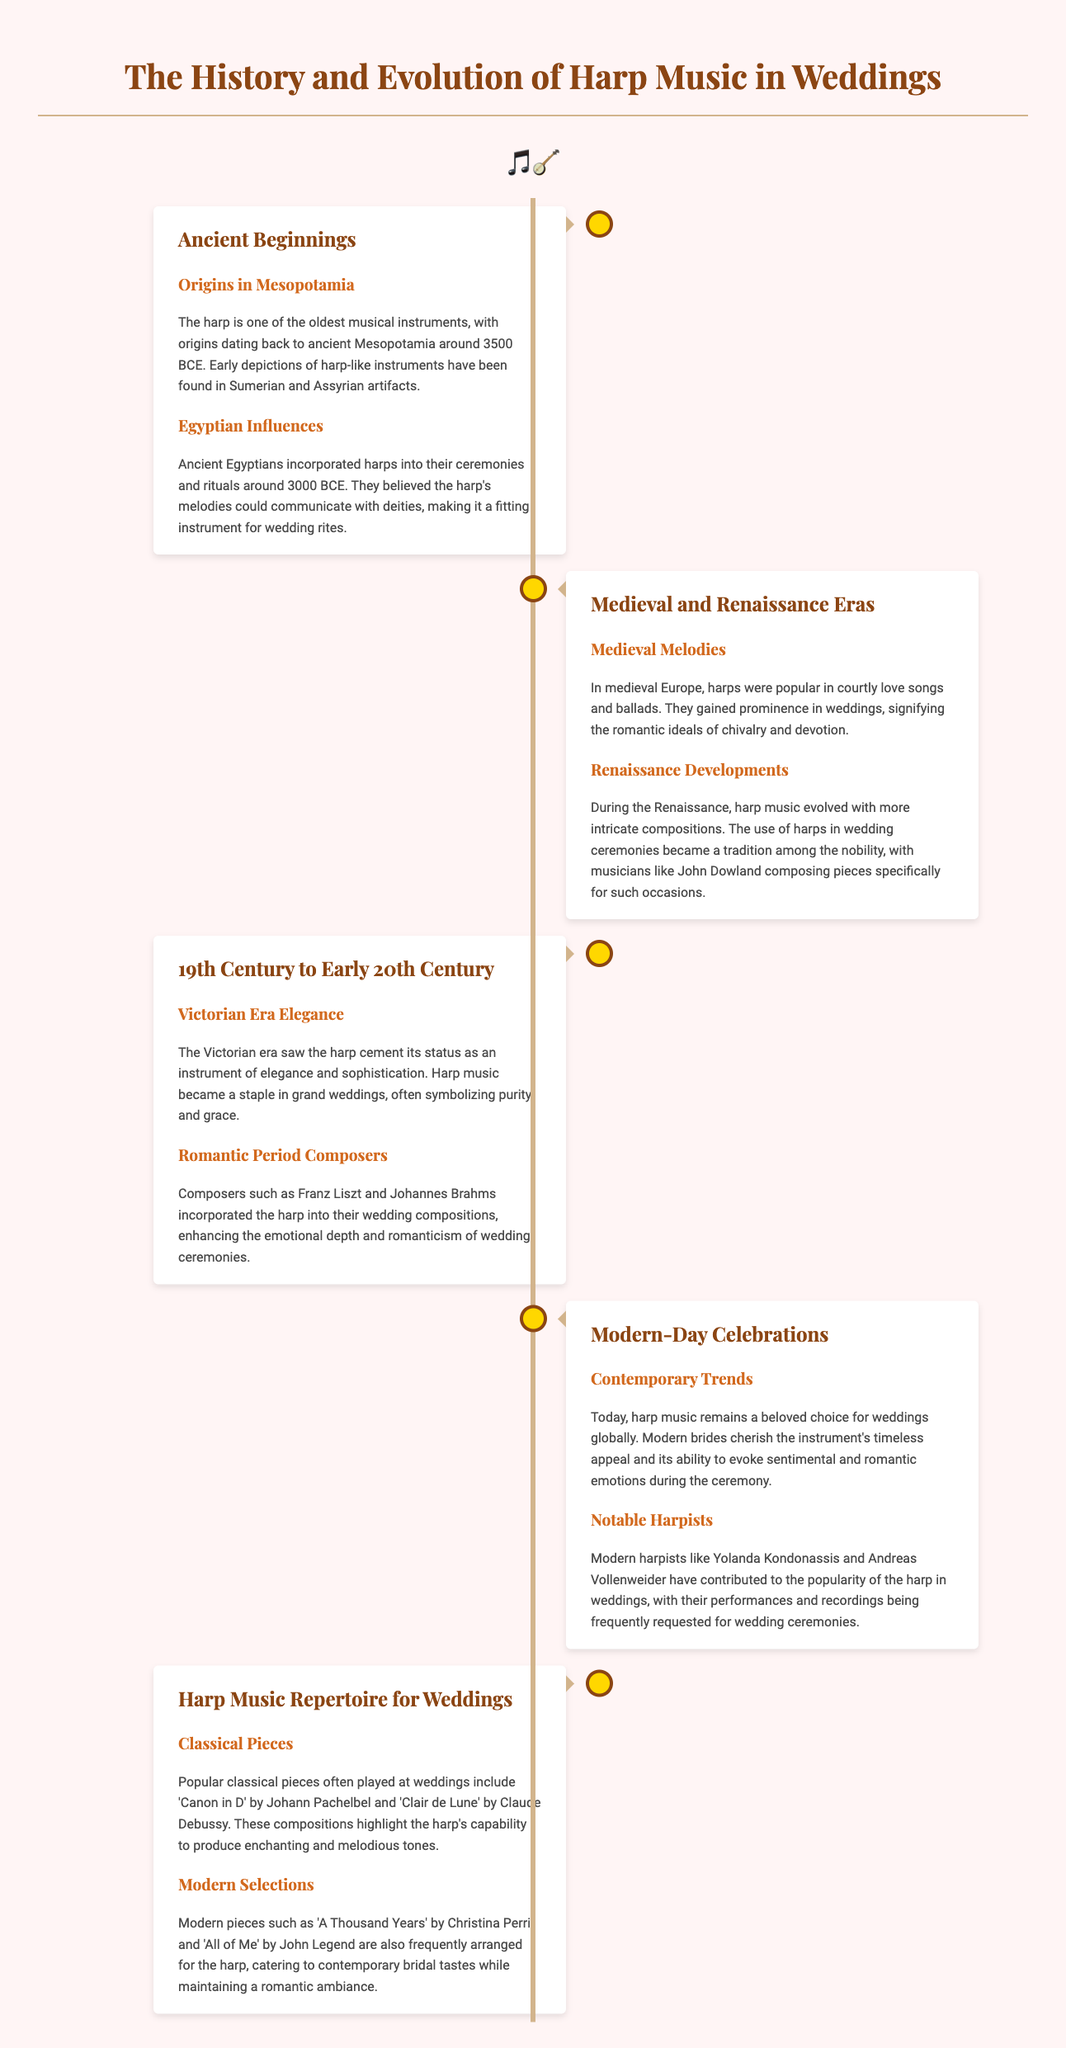What is the origin of the harp? The harp's origins date back to ancient Mesopotamia.
Answer: ancient Mesopotamia Around what year did Egyptians start using harps? Egyptians incorporated harps into ceremonies around 3000 BCE.
Answer: 3000 BCE Who composed pieces specifically for weddings during the Renaissance? Musicians like John Dowland composed pieces for weddings.
Answer: John Dowland What era solidified the harp's status as an elegant instrument? The Victorian era saw the harp cement its status as elegant.
Answer: Victorian era Name a modern harpist mentioned in the document. Yolanda Kondonassis is a notable modern harpist.
Answer: Yolanda Kondonassis What is a popular classical piece often played at weddings? 'Canon in D' by Johann Pachelbel is frequently played at weddings.
Answer: Canon in D Which modern piece is arranged for the harp according to contemporary tastes? 'A Thousand Years' by Christina Perri is a modern selection for harp.
Answer: A Thousand Years What instrument symbolizes purity and grace in weddings? The harp symbolizes purity and grace in weddings.
Answer: harp In which period did harp music begin to signify romantic ideals in weddings? Harp music gained prominence in weddings during the Medieval period.
Answer: Medieval 